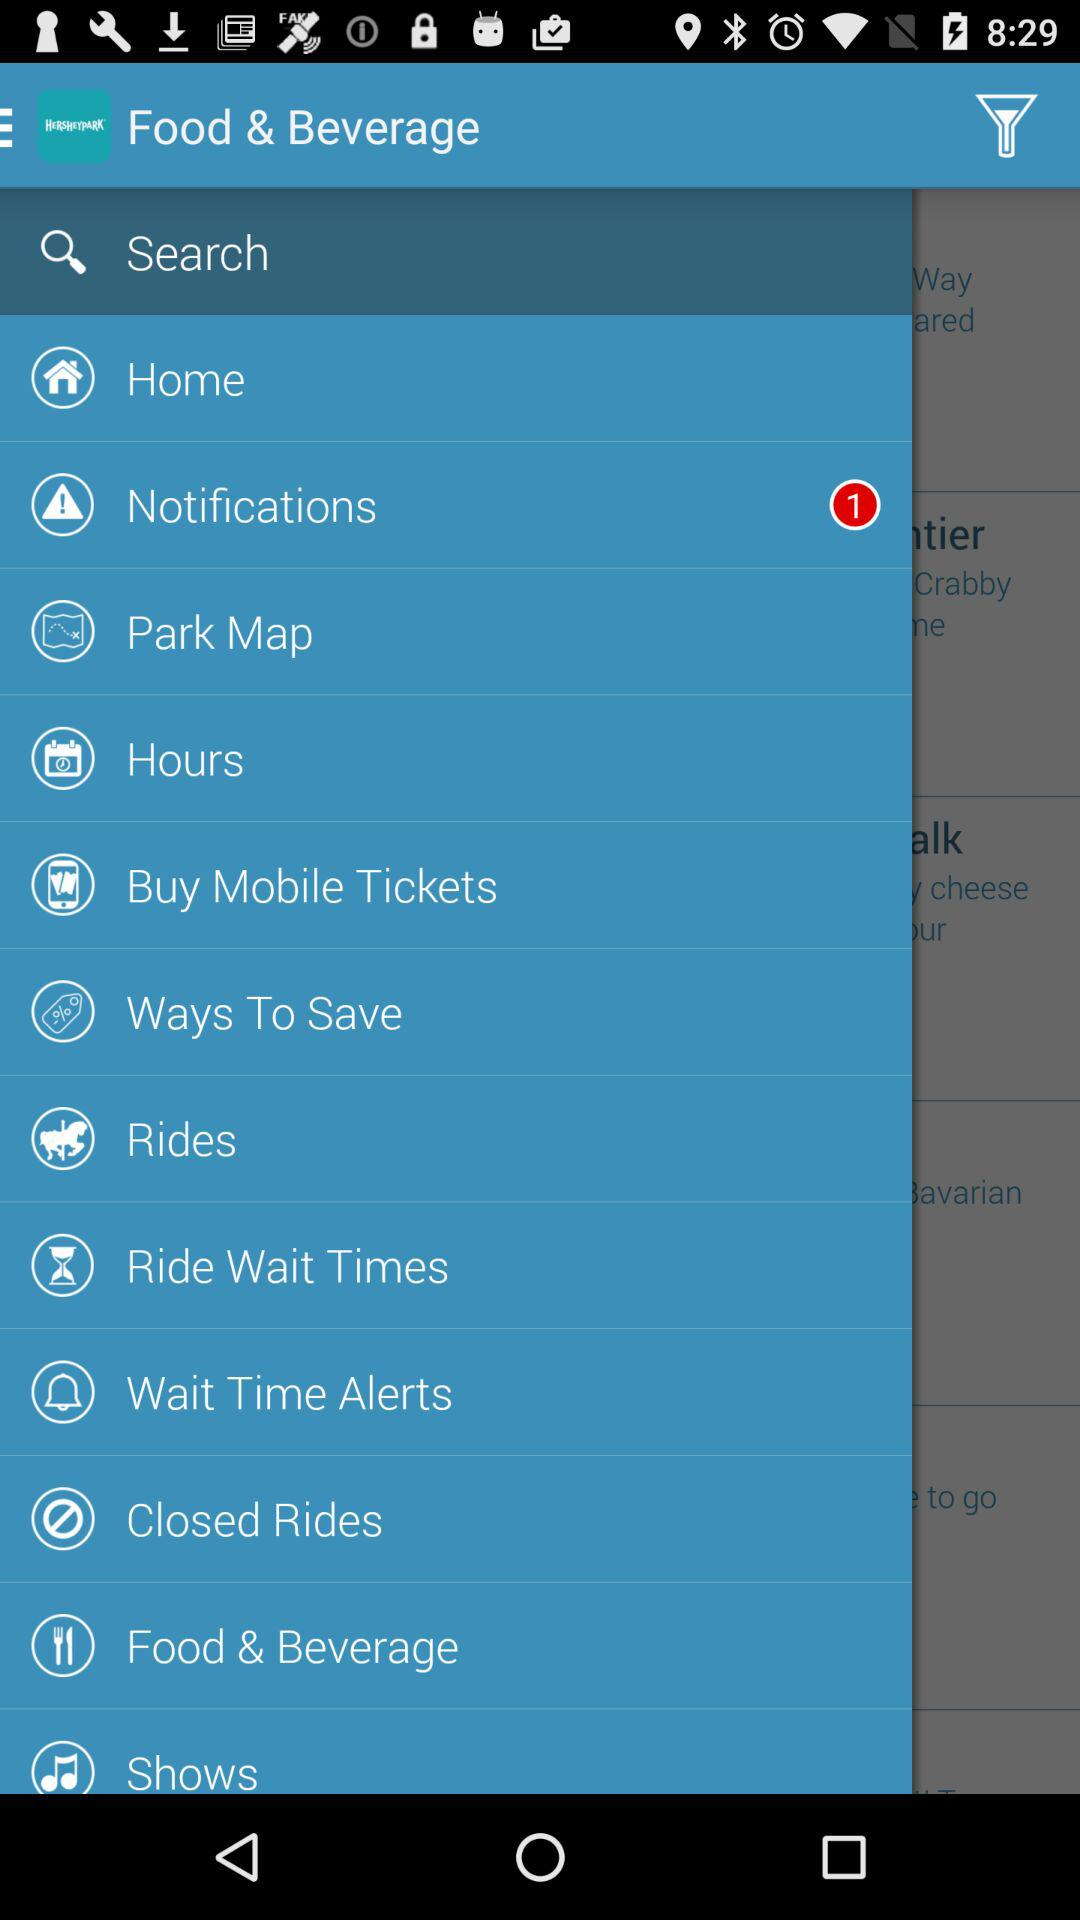What is the application name? The application name is "HERSHEYPARK". 